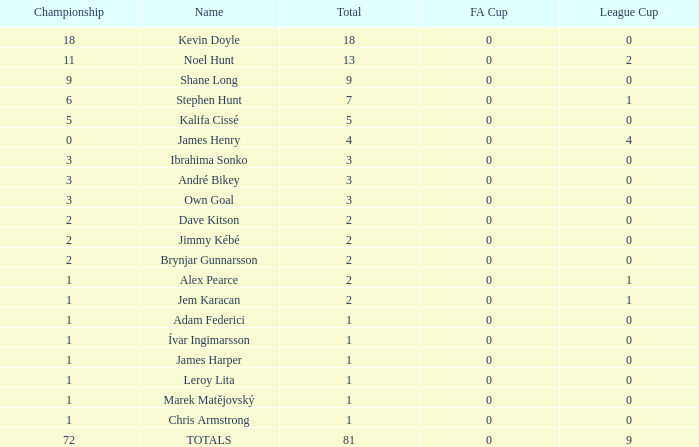What is the championship of Jem Karacan that has a total of 2 and a league cup more than 0? 1.0. 